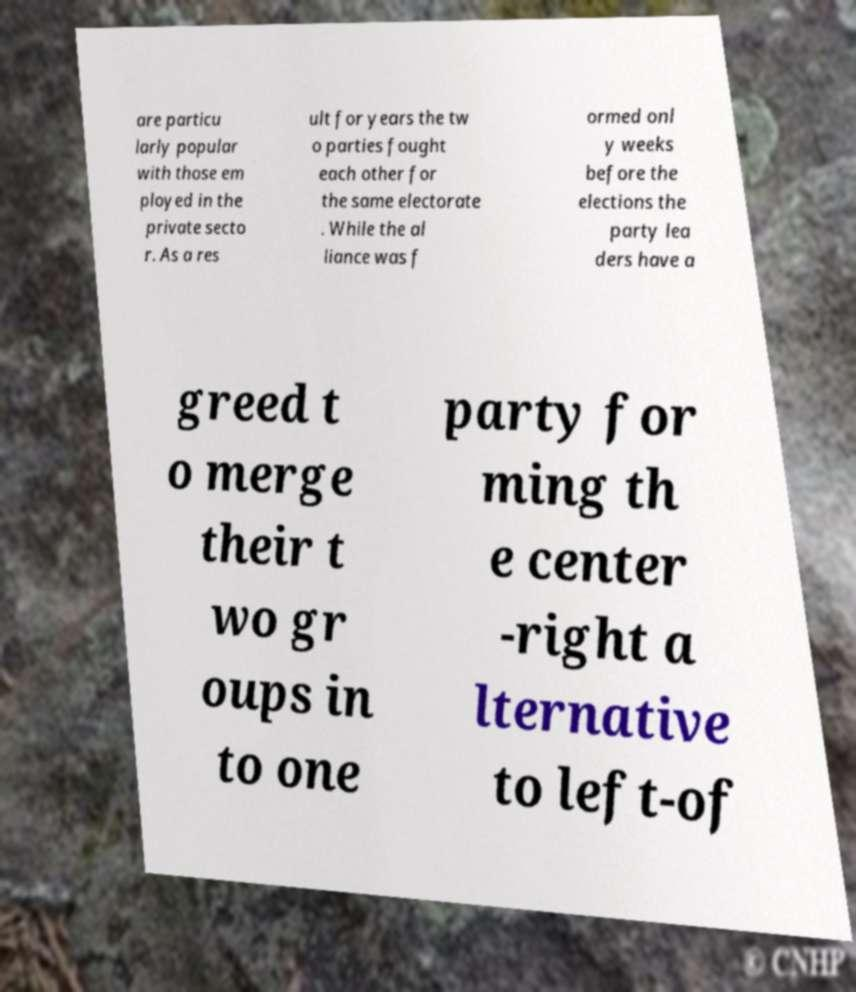Could you assist in decoding the text presented in this image and type it out clearly? are particu larly popular with those em ployed in the private secto r. As a res ult for years the tw o parties fought each other for the same electorate . While the al liance was f ormed onl y weeks before the elections the party lea ders have a greed t o merge their t wo gr oups in to one party for ming th e center -right a lternative to left-of 